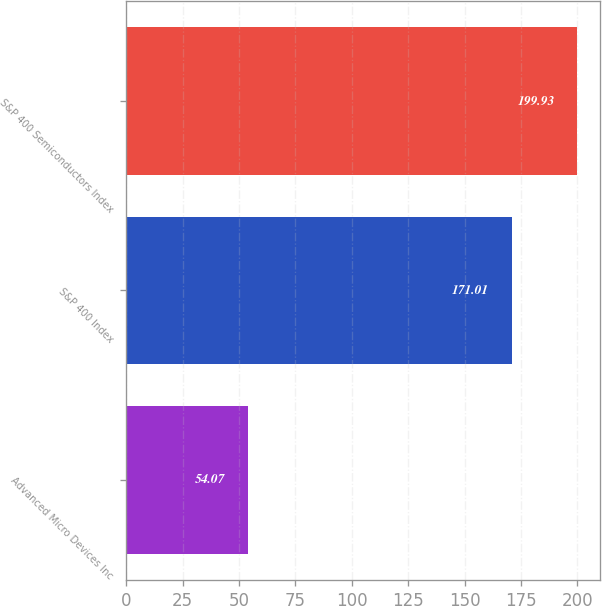<chart> <loc_0><loc_0><loc_500><loc_500><bar_chart><fcel>Advanced Micro Devices Inc<fcel>S&P 400 Index<fcel>S&P 400 Semiconductors Index<nl><fcel>54.07<fcel>171.01<fcel>199.93<nl></chart> 